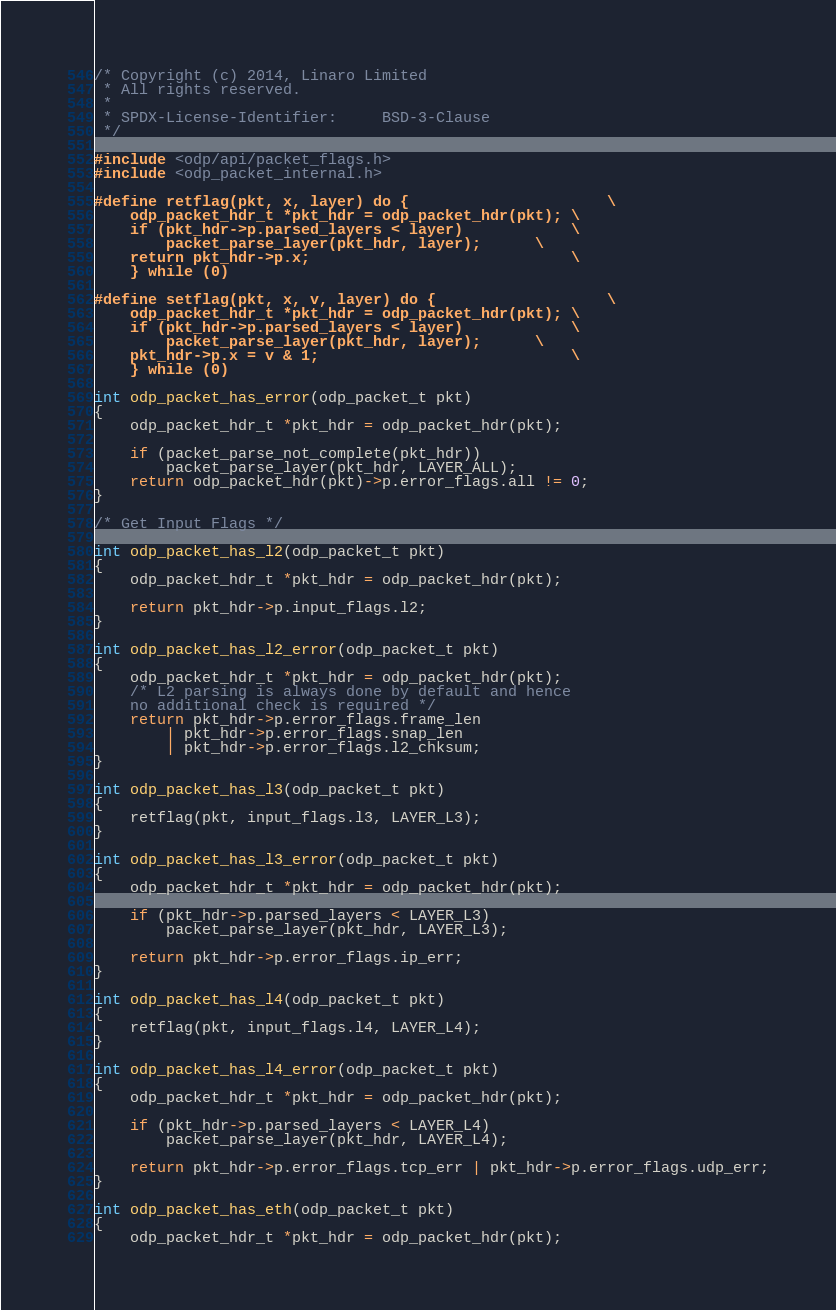Convert code to text. <code><loc_0><loc_0><loc_500><loc_500><_C_>/* Copyright (c) 2014, Linaro Limited
 * All rights reserved.
 *
 * SPDX-License-Identifier:     BSD-3-Clause
 */

#include <odp/api/packet_flags.h>
#include <odp_packet_internal.h>

#define retflag(pkt, x, layer) do {                      \
	odp_packet_hdr_t *pkt_hdr = odp_packet_hdr(pkt); \
	if (pkt_hdr->p.parsed_layers < layer)            \
		packet_parse_layer(pkt_hdr, layer);      \
	return pkt_hdr->p.x;                             \
	} while (0)

#define setflag(pkt, x, v, layer) do {                   \
	odp_packet_hdr_t *pkt_hdr = odp_packet_hdr(pkt); \
	if (pkt_hdr->p.parsed_layers < layer)            \
		packet_parse_layer(pkt_hdr, layer);      \
	pkt_hdr->p.x = v & 1;                            \
	} while (0)

int odp_packet_has_error(odp_packet_t pkt)
{
	odp_packet_hdr_t *pkt_hdr = odp_packet_hdr(pkt);

	if (packet_parse_not_complete(pkt_hdr))
		packet_parse_layer(pkt_hdr, LAYER_ALL);
	return odp_packet_hdr(pkt)->p.error_flags.all != 0;
}

/* Get Input Flags */

int odp_packet_has_l2(odp_packet_t pkt)
{
	odp_packet_hdr_t *pkt_hdr = odp_packet_hdr(pkt);

	return pkt_hdr->p.input_flags.l2;
}

int odp_packet_has_l2_error(odp_packet_t pkt)
{
	odp_packet_hdr_t *pkt_hdr = odp_packet_hdr(pkt);
	/* L2 parsing is always done by default and hence
	no additional check is required */
	return pkt_hdr->p.error_flags.frame_len
		| pkt_hdr->p.error_flags.snap_len
		| pkt_hdr->p.error_flags.l2_chksum;
}

int odp_packet_has_l3(odp_packet_t pkt)
{
	retflag(pkt, input_flags.l3, LAYER_L3);
}

int odp_packet_has_l3_error(odp_packet_t pkt)
{
	odp_packet_hdr_t *pkt_hdr = odp_packet_hdr(pkt);

	if (pkt_hdr->p.parsed_layers < LAYER_L3)
		packet_parse_layer(pkt_hdr, LAYER_L3);

	return pkt_hdr->p.error_flags.ip_err;
}

int odp_packet_has_l4(odp_packet_t pkt)
{
	retflag(pkt, input_flags.l4, LAYER_L4);
}

int odp_packet_has_l4_error(odp_packet_t pkt)
{
	odp_packet_hdr_t *pkt_hdr = odp_packet_hdr(pkt);

	if (pkt_hdr->p.parsed_layers < LAYER_L4)
		packet_parse_layer(pkt_hdr, LAYER_L4);

	return pkt_hdr->p.error_flags.tcp_err | pkt_hdr->p.error_flags.udp_err;
}

int odp_packet_has_eth(odp_packet_t pkt)
{
	odp_packet_hdr_t *pkt_hdr = odp_packet_hdr(pkt);
</code> 